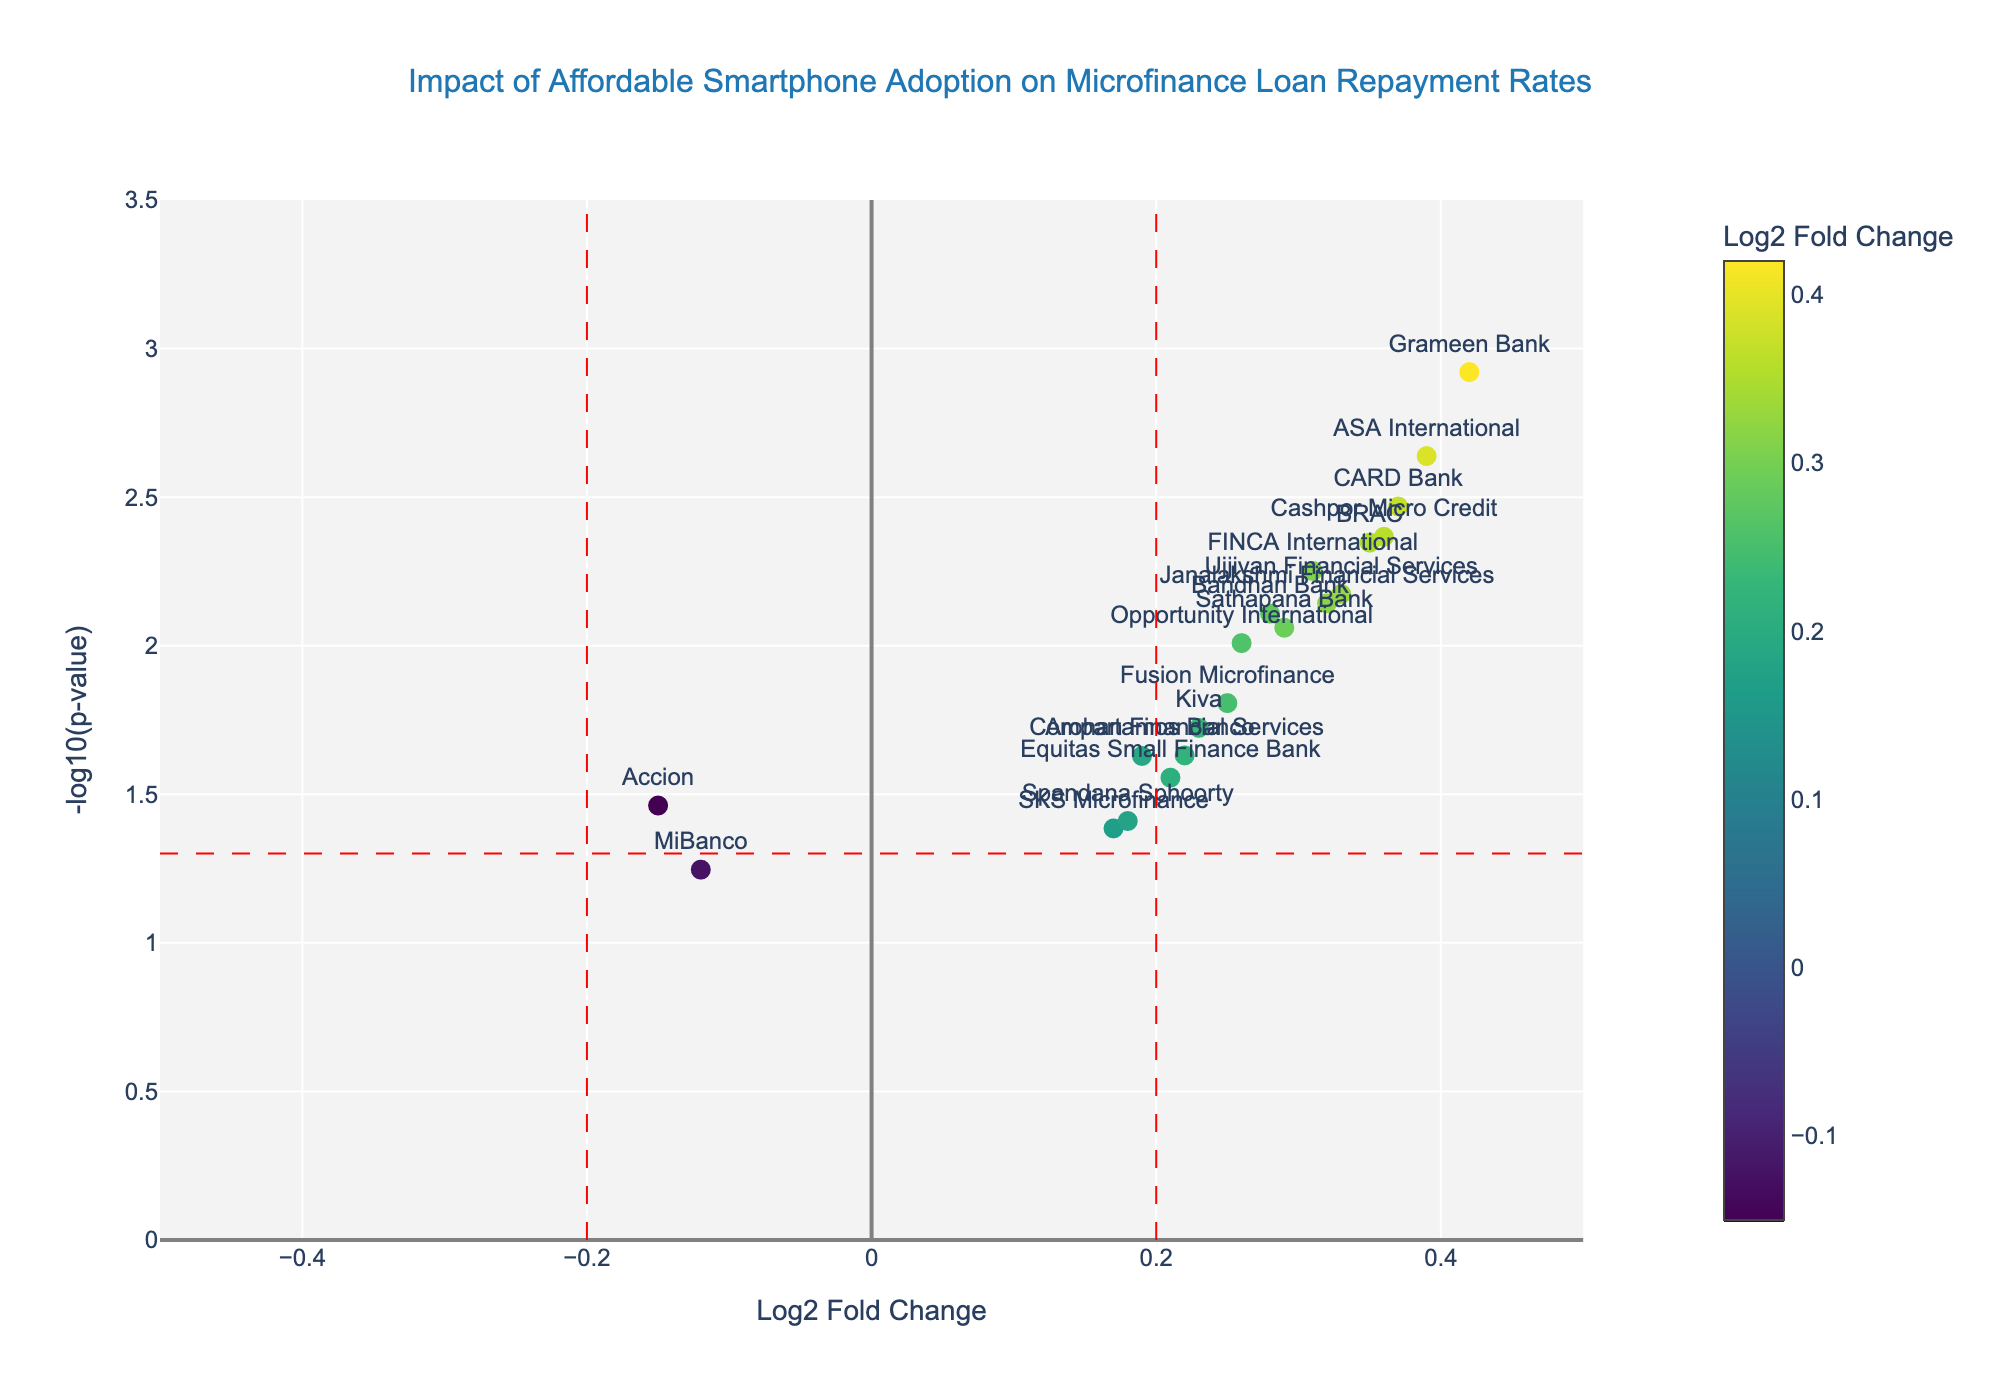what's the main title of the plot? The main title of a plot is usually found at the top center of the figure. It is often written in a larger and bolder font to distinguish it from other text. In this figure, the title is positioned as "Impact of Affordable Smartphone Adoption on Microfinance Loan Repayment Rates" based on the detailed description of the figure structure provided.
Answer: Impact of Affordable Smartphone Adoption on Microfinance Loan Repayment Rates How many microfinance institutions (MFIs) show a positive log2 fold change? A positive log2 fold change can be identified by examining the data points plotted on the right side of the x-axis, which is greater than 0. From the provided data: Grameen Bank, BRAC, Bandhan Bank, Compartamos Banco, FINCA International, Kiva, ASA International, SKS Microfinance, Opportunity International, Ujjivan Financial Services, Equitas Small Finance Bank, Sathapana Bank, CARD Bank, Fusion Microfinance, Spandana Sphoorty, Janalakshmi Financial Services, Arohan Financial Services, Cashpor Micro Credit all show positive log2 fold changes.
Answer: 18 Which MFI has the highest -log10(p-value)? The highest -log10(p-value) value corresponds to the point highest on the y-axis in the figure. From the data provided, Grameen Bank has the lowest p-value, thus the highest -log10(p-value) = 2.92, indicating it has the highest significance among the MFIs.
Answer: Grameen Bank Which MFI has a log2 fold change close to zero but is still significantly positive? A log2 fold change close to zero but still positive indicates a value just above zero. We also need to consider significant p-values (p < 0.05). From the provided data, SKS Microfinance has a log2 fold change of 0.17, which is close to zero and significant.
Answer: SKS Microfinance How many MFIs fall within the non-significant region (p-value > 0.05)? Non-significant values are those above the horizontal red dashed line at y = -log10(0.05). By looking at the data, we see MiBanco has a p-value > 0.05.
Answer: 1 Which MFI has the lowest log2 fold change and is it statistically significant? The MFI with the lowest log2 fold change (most negative value) can be identified by looking towards the left end of the x-axis. From the data, Accion has the lowest log2 fold change at -0.15. Since its p-value is 0.0345, it is statistically significant (below 0.05).
Answer: Accion What is the average log2 fold change for the top three most statistically significant MFIs? The top three statistically significant MFIs have the lowest p-values, which are Grameen Bank, ASA International, and CARD Bank. Their log2 fold changes are 0.42, 0.39, and 0.37 respectively. The average is calculated as (0.42 + 0.39 + 0.37) / 3 = 1.18 / 3.
Answer: 0.3933 Between BRAC and Kiva, which MFI exhibits a stronger positive correlation with affordable smartphone adoption in terms of loan repayment rates? A stronger positive correlation can be identified by the higher log2 fold change value. BRAC has a log2 fold change of 0.35, while Kiva has 0.23. Therefore, BRAC exhibits a stronger positive correlation.
Answer: BRAC Is there any MFI with a log2 fold change less than -0.1? If yes, name them. To determine this, we look for the log2 fold change values less than -0.1. From the provided data, Accion and MiBanco have log2 fold changes of -0.15 and -0.12 respectively.
Answer: Accion, MiBanco 